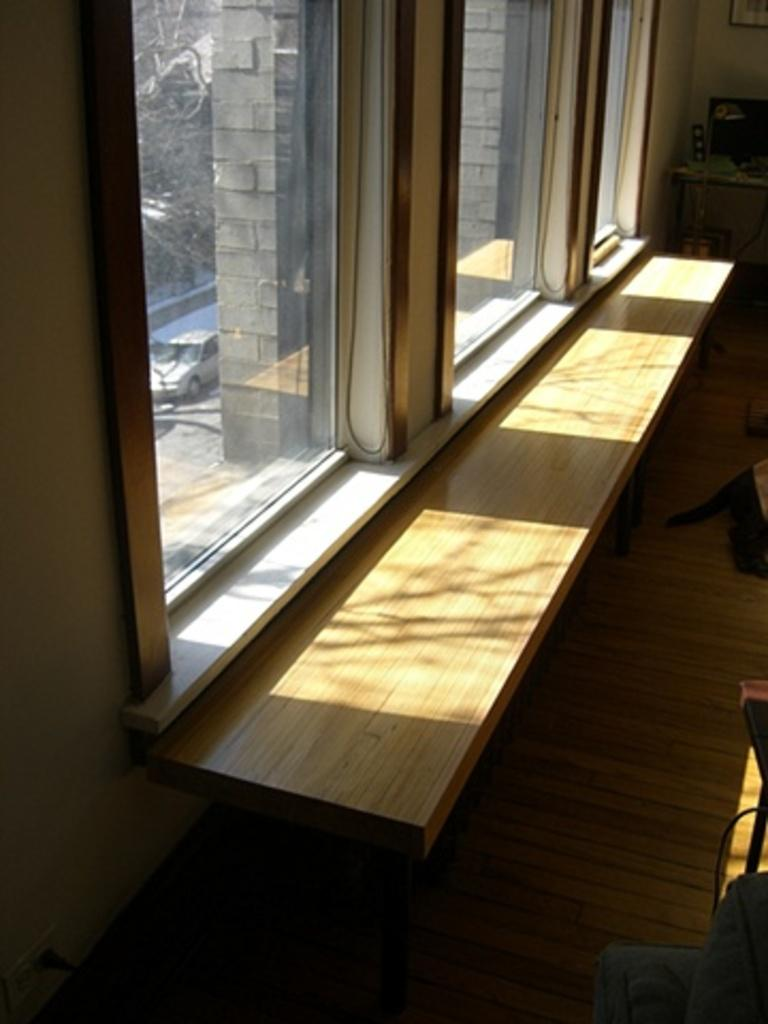What can be seen in the image that allows light to enter the room? There is a window in the image that allows bright sunlight to enter the room. What is located in front of the window? There is a shelf before the window. Can you describe the lighting conditions in the room based on the image? The room appears to be well-lit due to the bright sunlight visible through the window. Where is the nest located in the image? There is no nest present in the image. What color is the paint on the wall next to the window? There is no information about the wall color or the presence of paint in the image. 